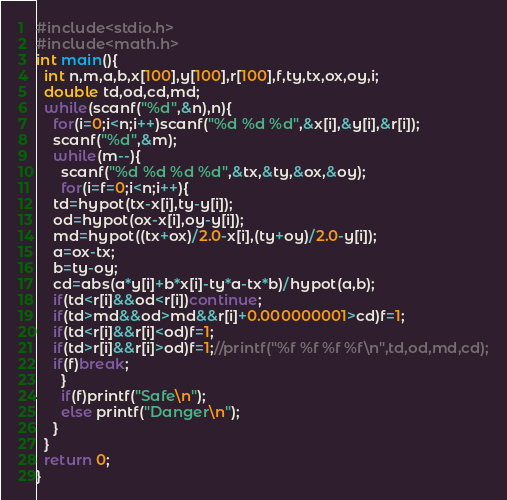<code> <loc_0><loc_0><loc_500><loc_500><_C_>#include<stdio.h>
#include<math.h>
int main(){
  int n,m,a,b,x[100],y[100],r[100],f,ty,tx,ox,oy,i;
  double td,od,cd,md;
  while(scanf("%d",&n),n){
    for(i=0;i<n;i++)scanf("%d %d %d",&x[i],&y[i],&r[i]);
    scanf("%d",&m);
    while(m--){
      scanf("%d %d %d %d",&tx,&ty,&ox,&oy);
      for(i=f=0;i<n;i++){
	td=hypot(tx-x[i],ty-y[i]);
	od=hypot(ox-x[i],oy-y[i]);
	md=hypot((tx+ox)/2.0-x[i],(ty+oy)/2.0-y[i]);
	a=ox-tx;
	b=ty-oy;
	cd=abs(a*y[i]+b*x[i]-ty*a-tx*b)/hypot(a,b);
	if(td<r[i]&&od<r[i])continue;
	if(td>md&&od>md&&r[i]+0.000000001>cd)f=1;
	if(td<r[i]&&r[i]<od)f=1;
	if(td>r[i]&&r[i]>od)f=1;//printf("%f %f %f %f\n",td,od,md,cd);
	if(f)break;
      }
      if(f)printf("Safe\n");
      else printf("Danger\n");
    }
  }
  return 0;
}</code> 